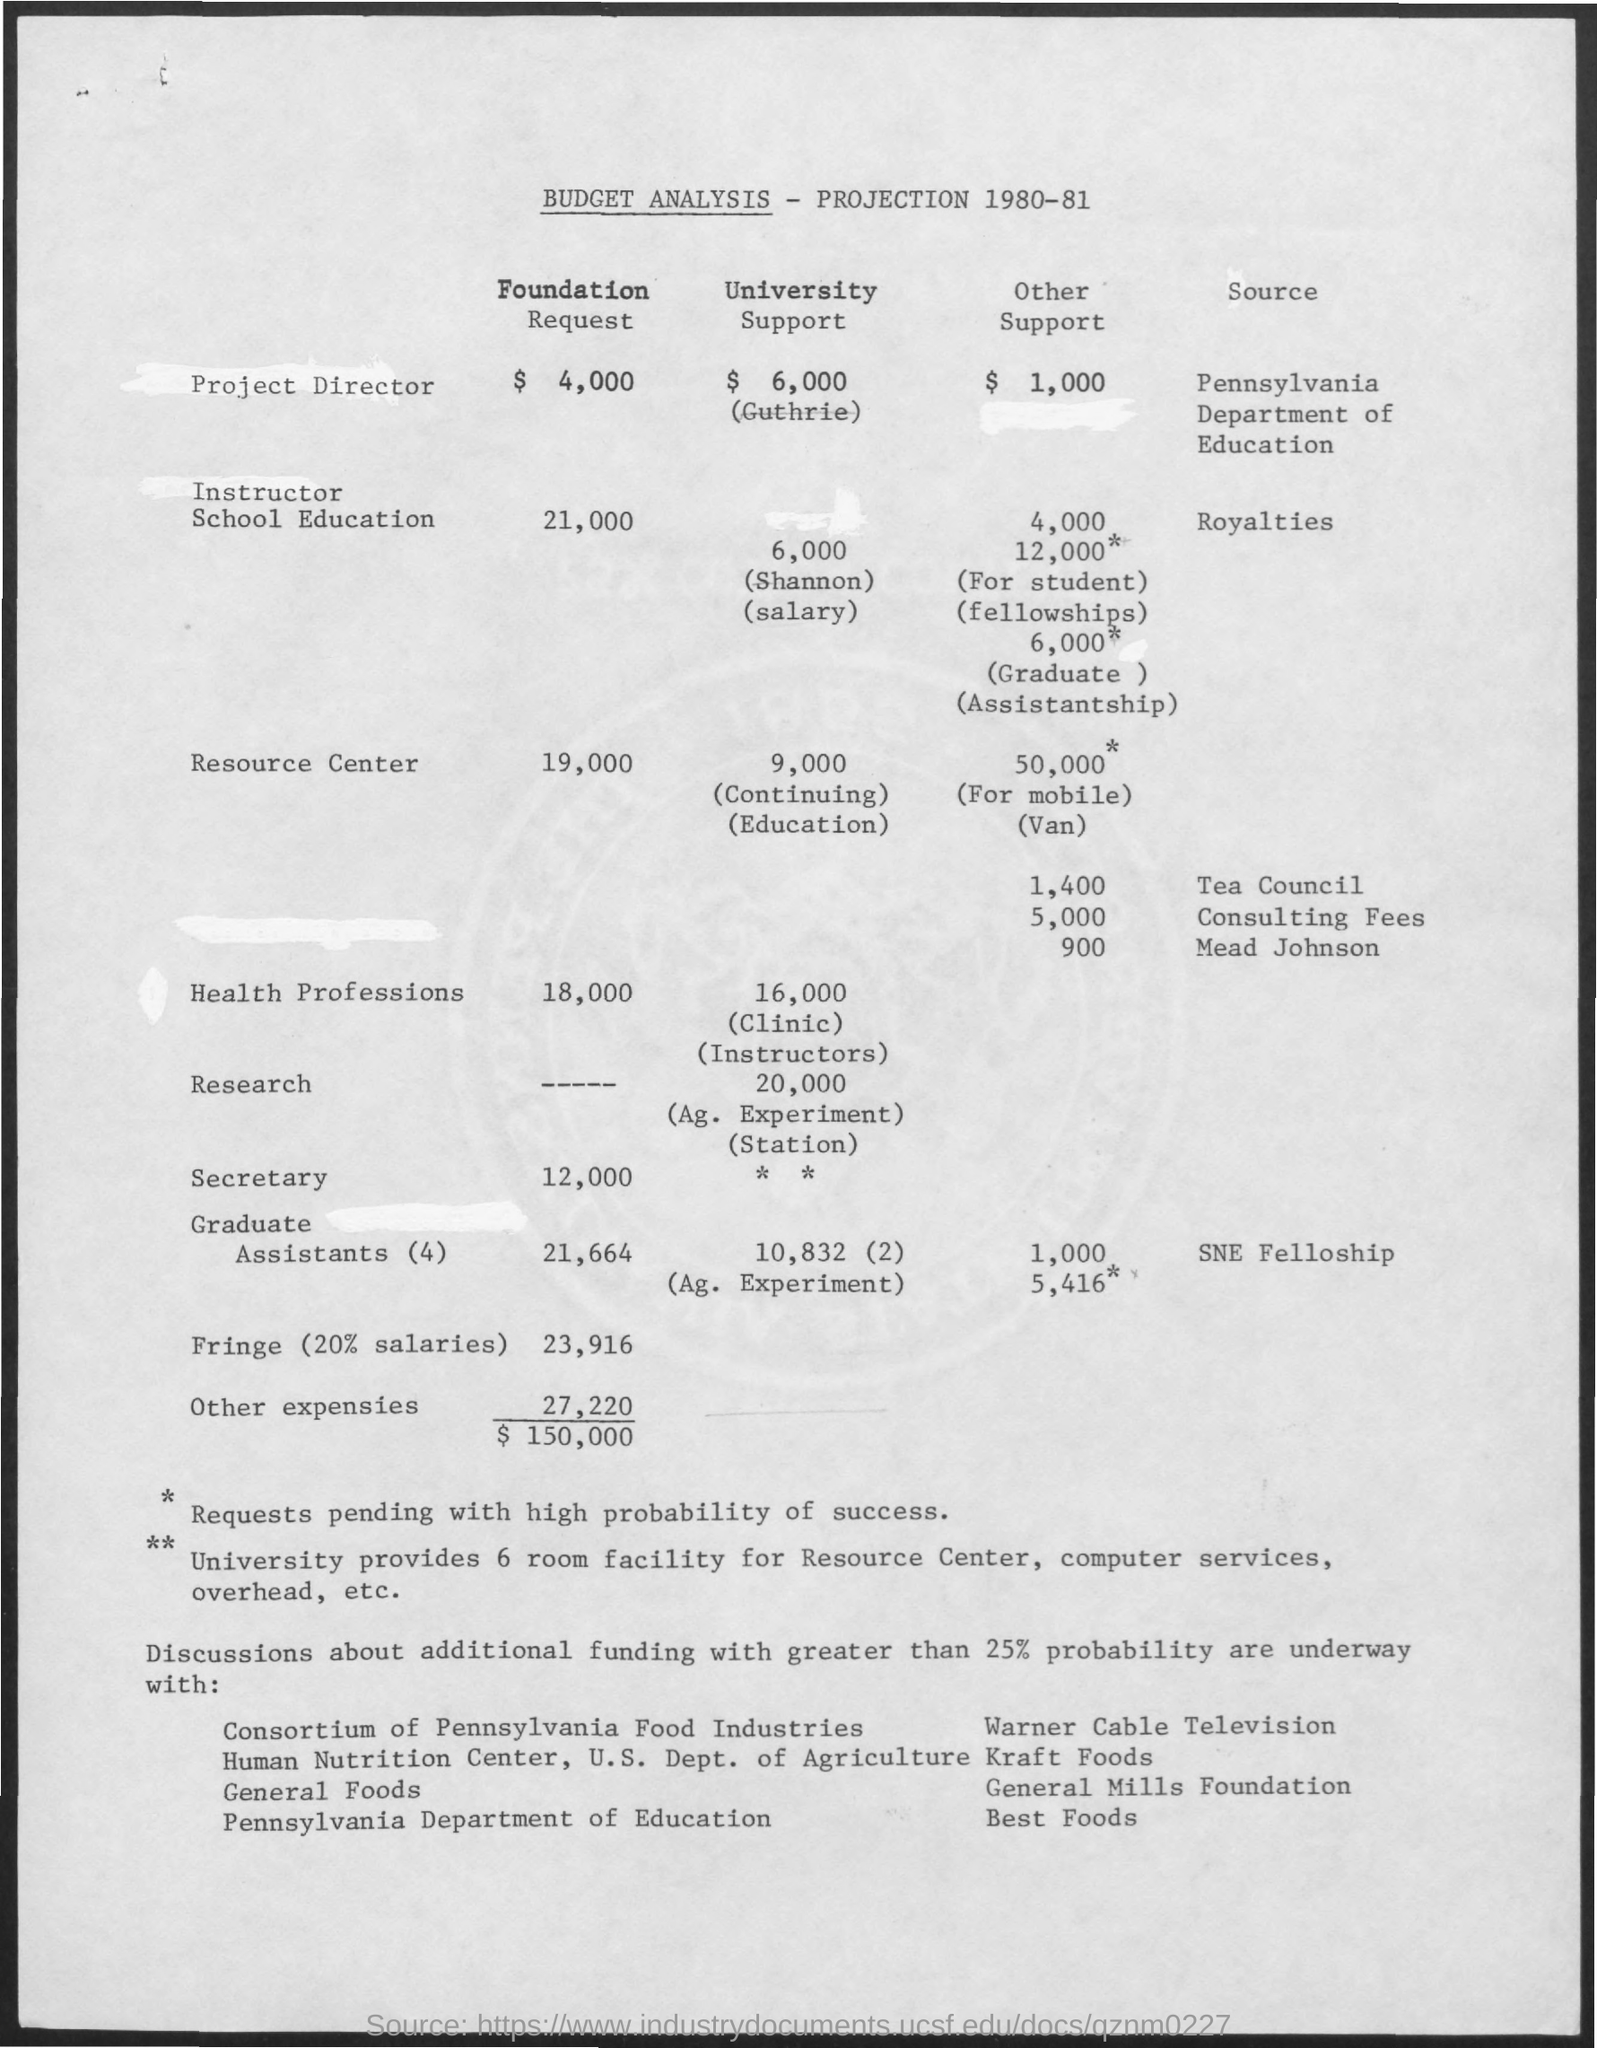List a handful of essential elements in this visual. The amount mentioned for the resource center in the foundation request is $19,000. The amount mentioned for the secretary in the foundation request is 12,000. The amount for instructor school education in university support is $6,000. The amount for the project director in the foundation request is $4,000. The requested amount for health professions in the foundation is 18,000. 